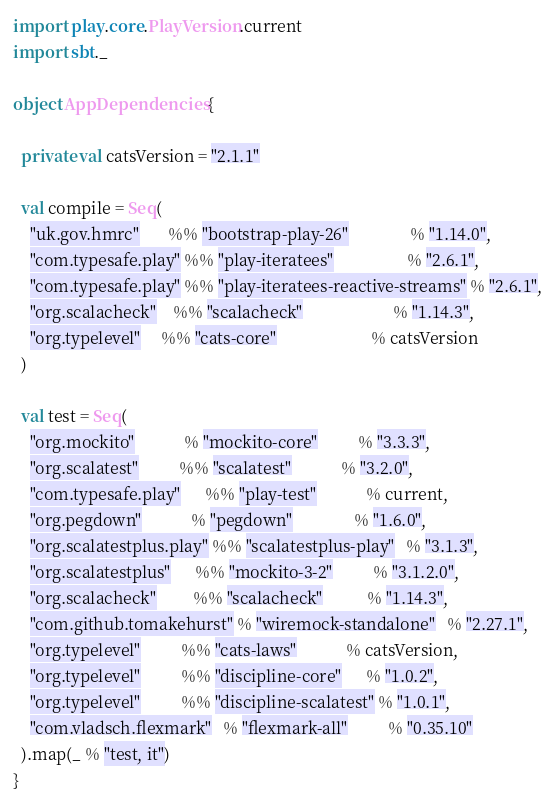Convert code to text. <code><loc_0><loc_0><loc_500><loc_500><_Scala_>import play.core.PlayVersion.current
import sbt._

object AppDependencies {

  private val catsVersion = "2.1.1"

  val compile = Seq(
    "uk.gov.hmrc"       %% "bootstrap-play-26"               % "1.14.0",
    "com.typesafe.play" %% "play-iteratees"                  % "2.6.1",
    "com.typesafe.play" %% "play-iteratees-reactive-streams" % "2.6.1",
    "org.scalacheck"    %% "scalacheck"                      % "1.14.3",
    "org.typelevel"     %% "cats-core"                       % catsVersion
  )

  val test = Seq(
    "org.mockito"            % "mockito-core"          % "3.3.3",
    "org.scalatest"          %% "scalatest"            % "3.2.0",
    "com.typesafe.play"      %% "play-test"            % current,
    "org.pegdown"            % "pegdown"               % "1.6.0",
    "org.scalatestplus.play" %% "scalatestplus-play"   % "3.1.3",
    "org.scalatestplus"      %% "mockito-3-2"          % "3.1.2.0",
    "org.scalacheck"         %% "scalacheck"           % "1.14.3",
    "com.github.tomakehurst" % "wiremock-standalone"   % "2.27.1",
    "org.typelevel"          %% "cats-laws"            % catsVersion,
    "org.typelevel"          %% "discipline-core"      % "1.0.2",
    "org.typelevel"          %% "discipline-scalatest" % "1.0.1",
    "com.vladsch.flexmark"   % "flexmark-all"          % "0.35.10"
  ).map(_ % "test, it")
}
</code> 